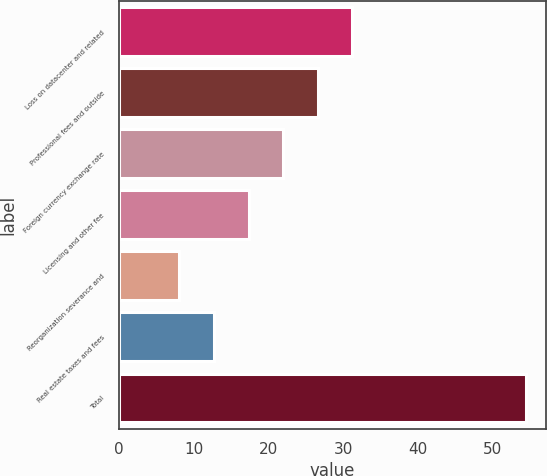Convert chart. <chart><loc_0><loc_0><loc_500><loc_500><bar_chart><fcel>Loss on datacenter and related<fcel>Professional fees and outside<fcel>Foreign currency exchange rate<fcel>Licensing and other fee<fcel>Reorganization severance and<fcel>Real estate taxes and fees<fcel>Total<nl><fcel>31.25<fcel>26.62<fcel>21.99<fcel>17.36<fcel>8.1<fcel>12.73<fcel>54.4<nl></chart> 